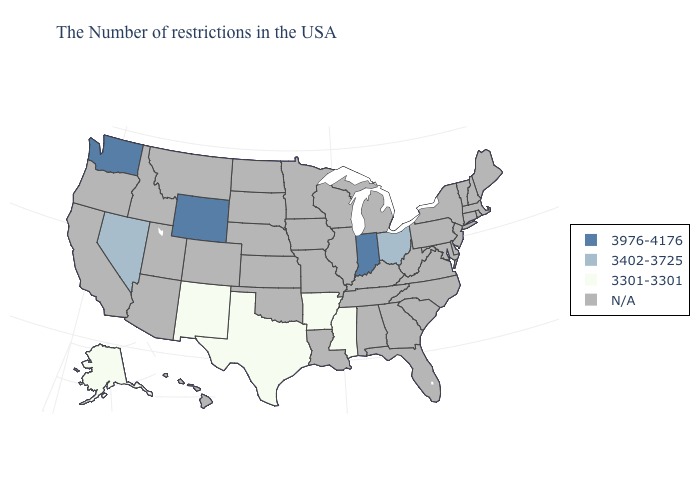What is the lowest value in the MidWest?
Answer briefly. 3402-3725. Name the states that have a value in the range 3402-3725?
Answer briefly. Ohio, Nevada. Name the states that have a value in the range 3402-3725?
Short answer required. Ohio, Nevada. Which states have the highest value in the USA?
Quick response, please. Indiana, Wyoming, Washington. What is the highest value in states that border Louisiana?
Be succinct. 3301-3301. Name the states that have a value in the range 3301-3301?
Concise answer only. Mississippi, Arkansas, Texas, New Mexico, Alaska. Does Washington have the highest value in the USA?
Answer briefly. Yes. What is the value of New York?
Keep it brief. N/A. What is the value of Idaho?
Answer briefly. N/A. What is the value of West Virginia?
Keep it brief. N/A. What is the lowest value in states that border Ohio?
Concise answer only. 3976-4176. What is the value of Arizona?
Write a very short answer. N/A. 